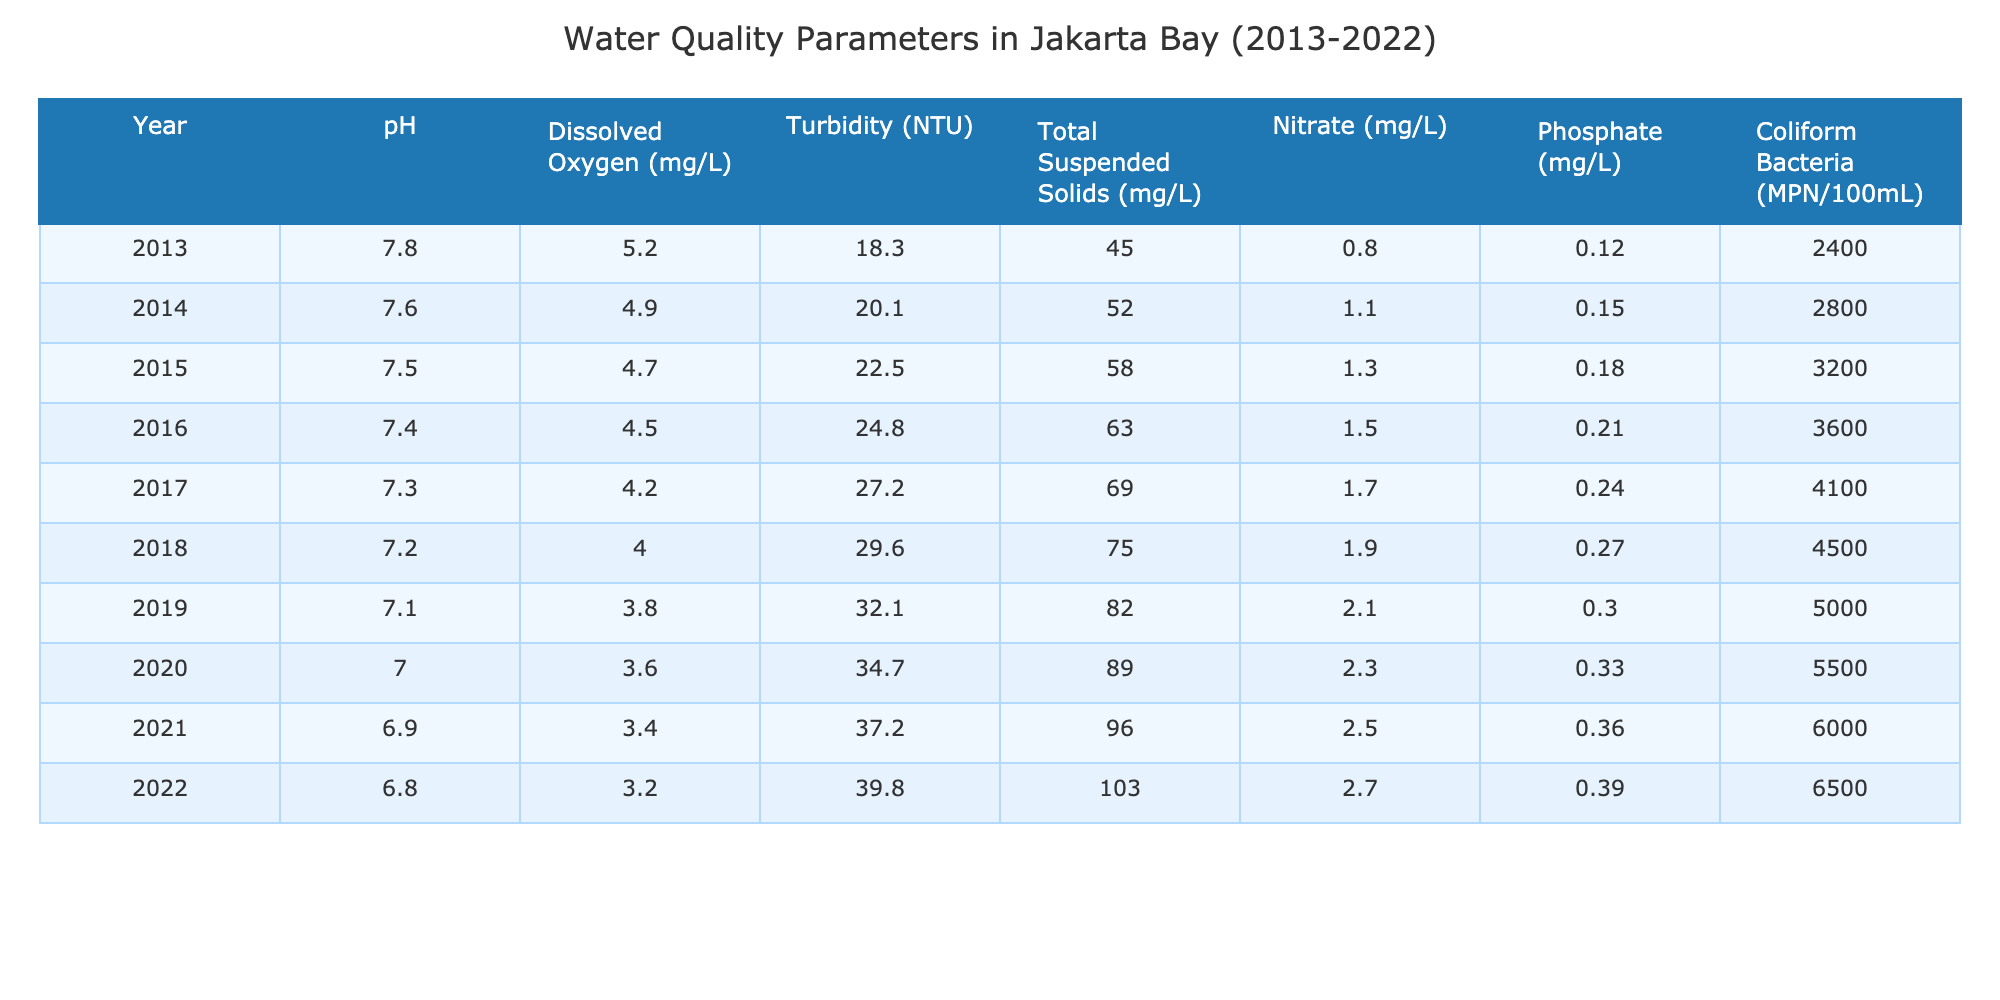What was the pH level in Jakarta Bay in 2013? The table shows that the pH level for the year 2013 is listed under the corresponding column, which indicates it was 7.8.
Answer: 7.8 What is the maximum level of Dissolved Oxygen recorded in the table? By reviewing the Dissolved Oxygen column, the maximum value listed is 5.2 mg/L, which corresponds to the year 2013.
Answer: 5.2 mg/L How much did the Turbidity increase from 2013 to 2022? The Turbidity in 2013 was 18.3 NTU, and in 2022, it was 39.8 NTU. The difference is calculated as 39.8 - 18.3 = 21.5 NTU.
Answer: 21.5 NTU Is there a trend in Nitrate levels over the years? Observing the Nitrate column, the levels increase from 0.8 mg/L in 2013 to 2.7 mg/L in 2022, indicating a consistent rise over the years. Therefore, the trend is increasing.
Answer: Yes What is the average level of Total Suspended Solids from 2013 to 2022? The sum of Total Suspended Solids from 2013 to 2022 is 45 + 52 + 58 + 63 + 69 + 75 + 82 + 89 + 96 + 103 =  833 mg/L. Divide by 10 years results in an average of 833/10 = 83.3 mg/L.
Answer: 83.3 mg/L Which year recorded the highest level of Coliform Bacteria? The Coliform Bacteria levels for each year can be evaluated, with the highest recorded value being 6500 MPN/100mL in 2022.
Answer: 2022 What is the trend in Phosphate levels from 2013 to 2022? Analyzing the Phosphate column, the values increase progressively from 0.12 mg/L in 2013 to 0.39 mg/L in 2022, which indicates a clear upward trend over the decade.
Answer: Increasing What is the change in average Dissolved Oxygen levels from the beginning to the end of the data set? The average dissolved oxygen levels for 2013-2022 are calculated: (5.2 + 4.9 + 4.7 + 4.5 + 4.2 + 4.0 + 3.8 + 3.6 + 3.4 + 3.2) / 10 = 4.27 mg/L. From the beginning in 2013 (5.2 mg/L) to the end in 2022 (3.2 mg/L), there is a decrease of 5.2 - 3.2 = 2.0 mg/L.
Answer: 2.0 mg/L How did the pH change over the decade? By examining the pH levels from 7.8 in 2013 to 6.8 in 2022, we observe a decrease of 1.0. Thus, the pH values have declined steadily each year.
Answer: Decreased by 1.0 In what year was the lowest level of Turbidity recorded? The lowest Turbidity recorded can be found in the table, which is 18.3 NTU in 2013.
Answer: 2013 